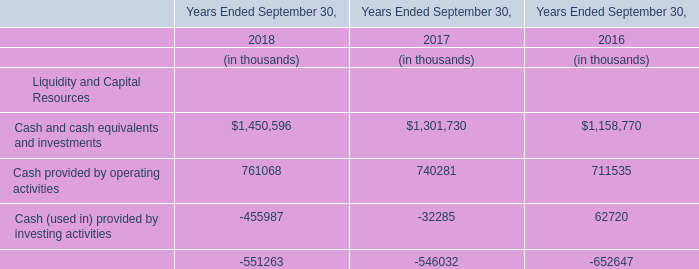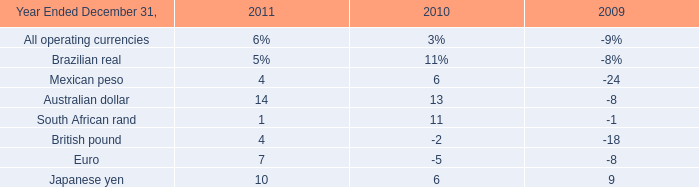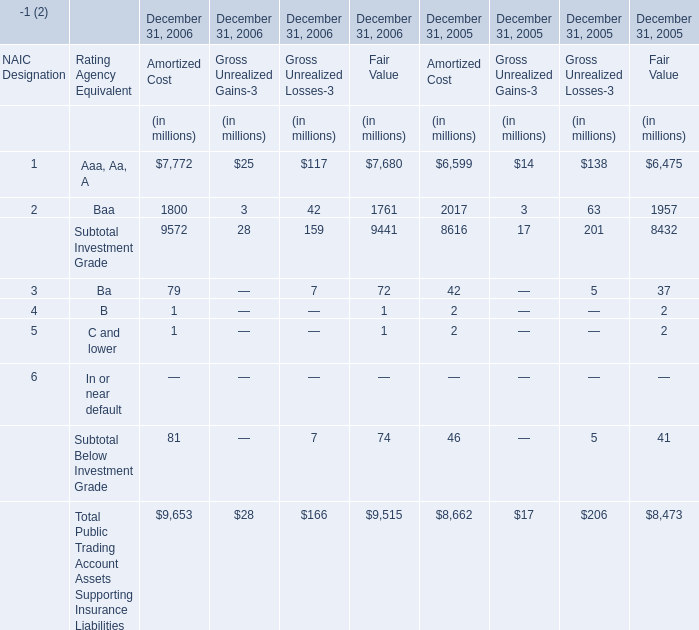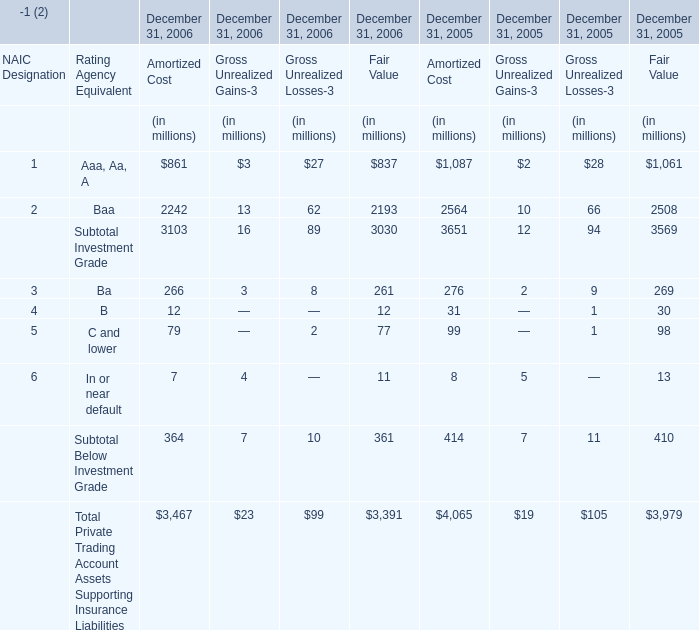What is the percentage of all Gross Unrealized Gains-3 that are positive to the total amount, in 2005? 
Computations: ((((2 + 10) + 2) + 5) / 19)
Answer: 1.0. 